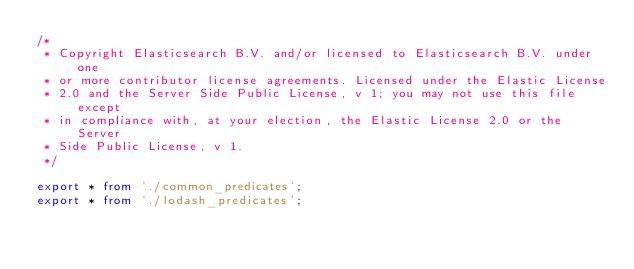Convert code to text. <code><loc_0><loc_0><loc_500><loc_500><_TypeScript_>/*
 * Copyright Elasticsearch B.V. and/or licensed to Elasticsearch B.V. under one
 * or more contributor license agreements. Licensed under the Elastic License
 * 2.0 and the Server Side Public License, v 1; you may not use this file except
 * in compliance with, at your election, the Elastic License 2.0 or the Server
 * Side Public License, v 1.
 */

export * from './common_predicates';
export * from './lodash_predicates';
</code> 